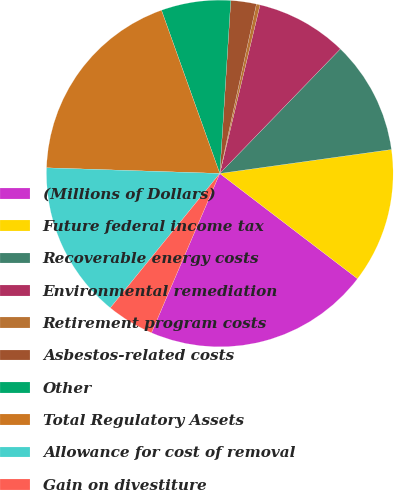Convert chart to OTSL. <chart><loc_0><loc_0><loc_500><loc_500><pie_chart><fcel>(Millions of Dollars)<fcel>Future federal income tax<fcel>Recoverable energy costs<fcel>Environmental remediation<fcel>Retirement program costs<fcel>Asbestos-related costs<fcel>Other<fcel>Total Regulatory Assets<fcel>Allowance for cost of removal<fcel>Gain on divestiture<nl><fcel>21.06%<fcel>12.59%<fcel>10.55%<fcel>8.51%<fcel>0.34%<fcel>2.38%<fcel>6.47%<fcel>19.02%<fcel>14.64%<fcel>4.43%<nl></chart> 